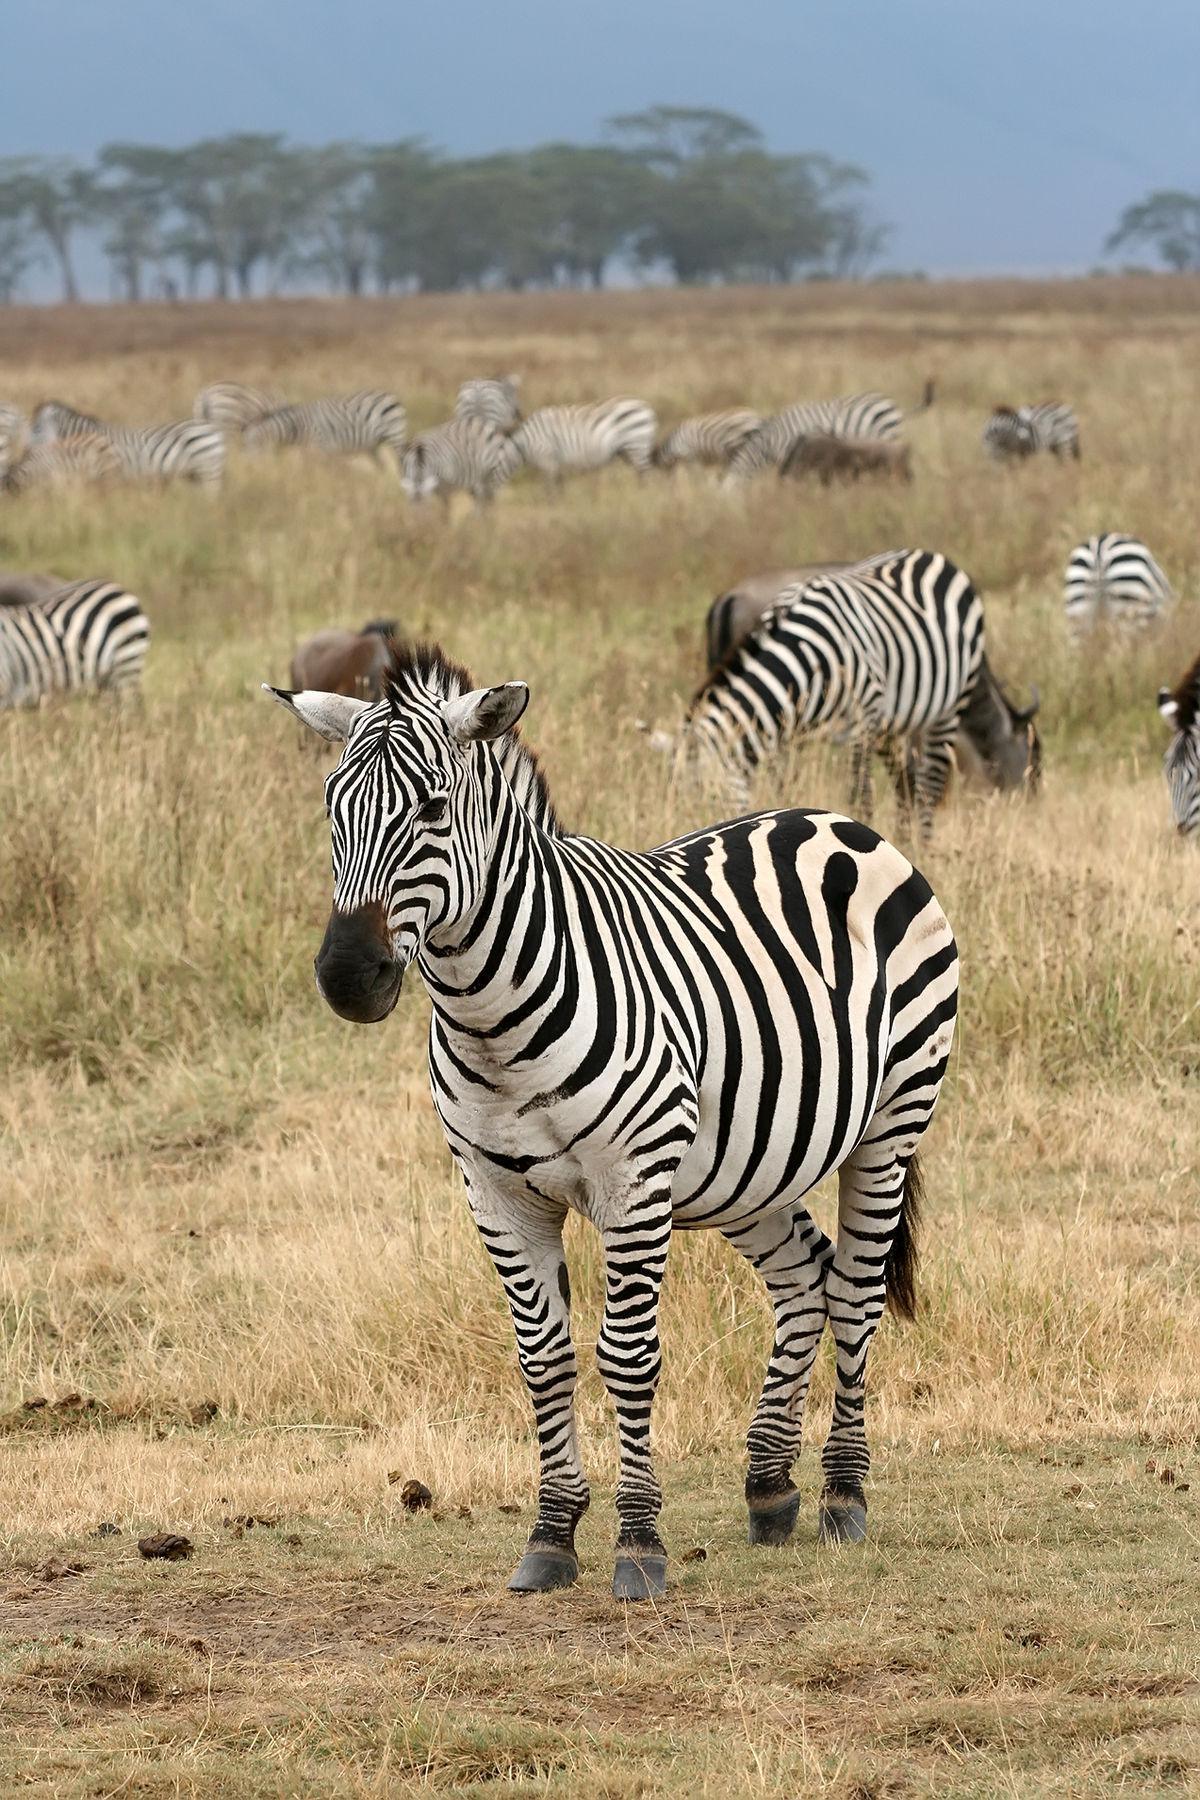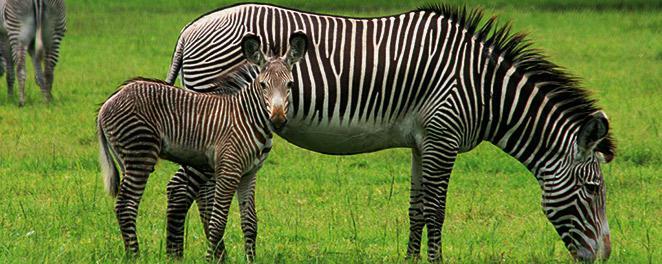The first image is the image on the left, the second image is the image on the right. Given the left and right images, does the statement "There are three zebras and one of them is a juvenile." hold true? Answer yes or no. No. 